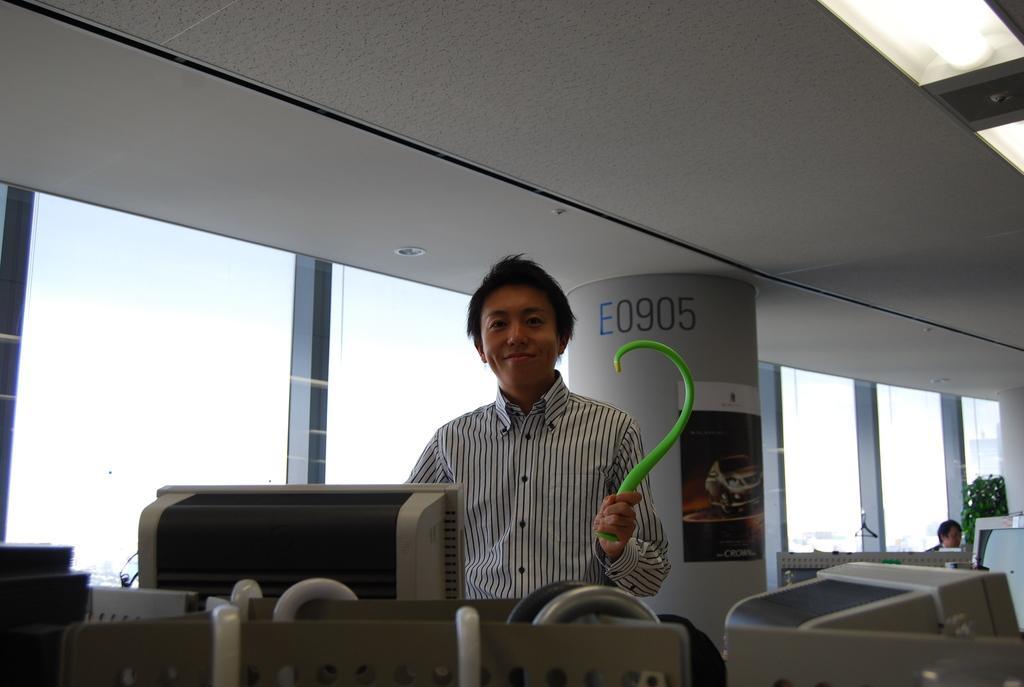Can you describe this image briefly? This image consists of a man wearing a black and white shirt. In front of him, there are computers. To the left, there are glass windows. At the top, there is a roof. 